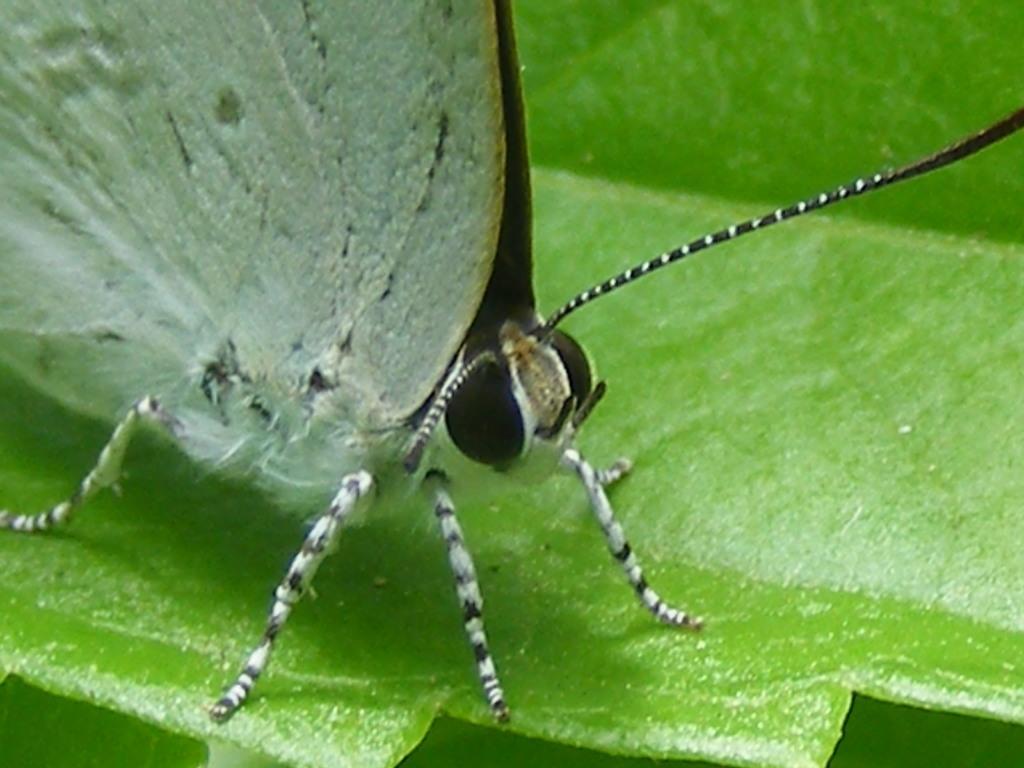Describe this image in one or two sentences. In this image we can see a butterfly on the leaf. 